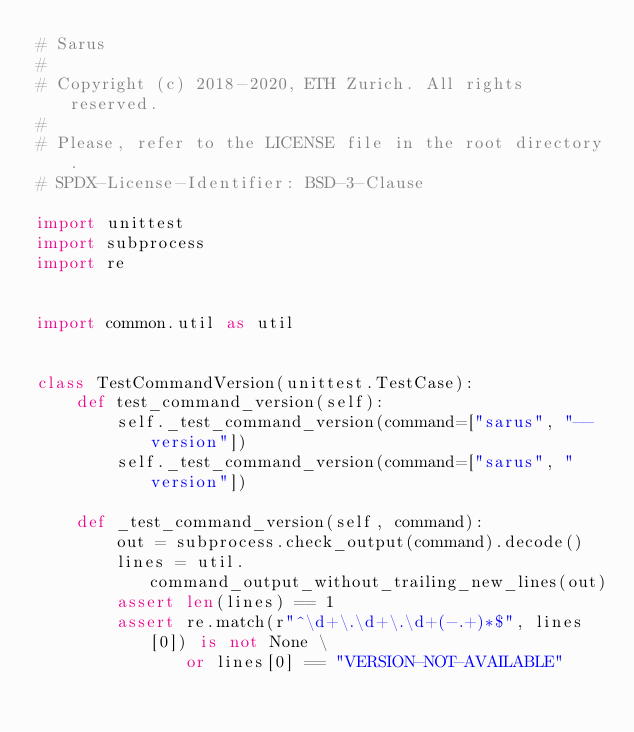<code> <loc_0><loc_0><loc_500><loc_500><_Python_># Sarus
#
# Copyright (c) 2018-2020, ETH Zurich. All rights reserved.
#
# Please, refer to the LICENSE file in the root directory.
# SPDX-License-Identifier: BSD-3-Clause

import unittest
import subprocess
import re


import common.util as util


class TestCommandVersion(unittest.TestCase):
    def test_command_version(self):
        self._test_command_version(command=["sarus", "--version"])
        self._test_command_version(command=["sarus", "version"])

    def _test_command_version(self, command):
        out = subprocess.check_output(command).decode()
        lines = util.command_output_without_trailing_new_lines(out)
        assert len(lines) == 1
        assert re.match(r"^\d+\.\d+\.\d+(-.+)*$", lines[0]) is not None \
               or lines[0] == "VERSION-NOT-AVAILABLE"
</code> 